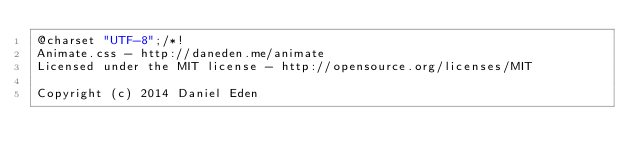Convert code to text. <code><loc_0><loc_0><loc_500><loc_500><_CSS_>@charset "UTF-8";/*!
Animate.css - http://daneden.me/animate
Licensed under the MIT license - http://opensource.org/licenses/MIT

Copyright (c) 2014 Daniel Eden</code> 